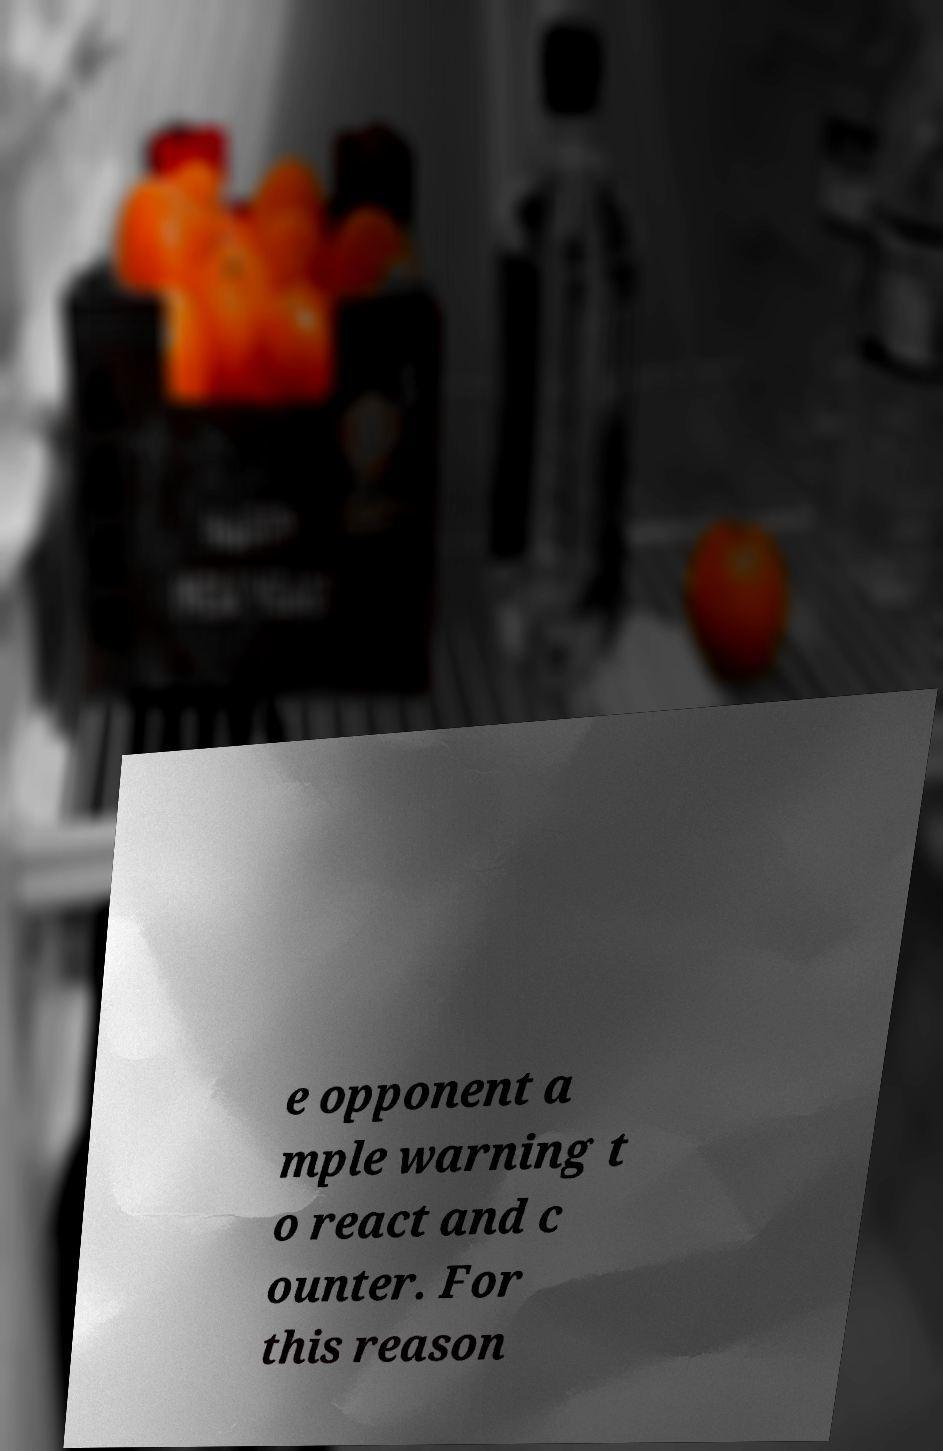Please identify and transcribe the text found in this image. e opponent a mple warning t o react and c ounter. For this reason 